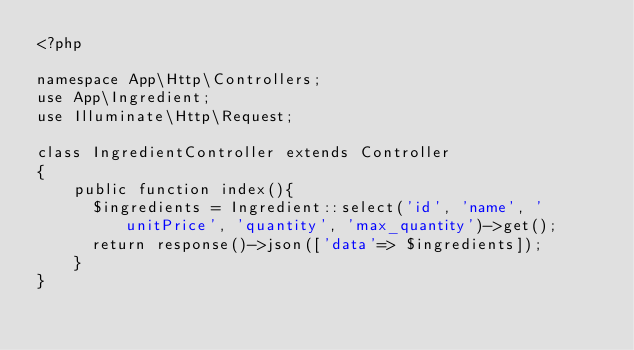Convert code to text. <code><loc_0><loc_0><loc_500><loc_500><_PHP_><?php

namespace App\Http\Controllers;
use App\Ingredient;
use Illuminate\Http\Request;

class IngredientController extends Controller
{
    public function index(){
    	$ingredients = Ingredient::select('id', 'name', 'unitPrice', 'quantity', 'max_quantity')->get();
    	return response()->json(['data'=> $ingredients]);
    }
}
</code> 